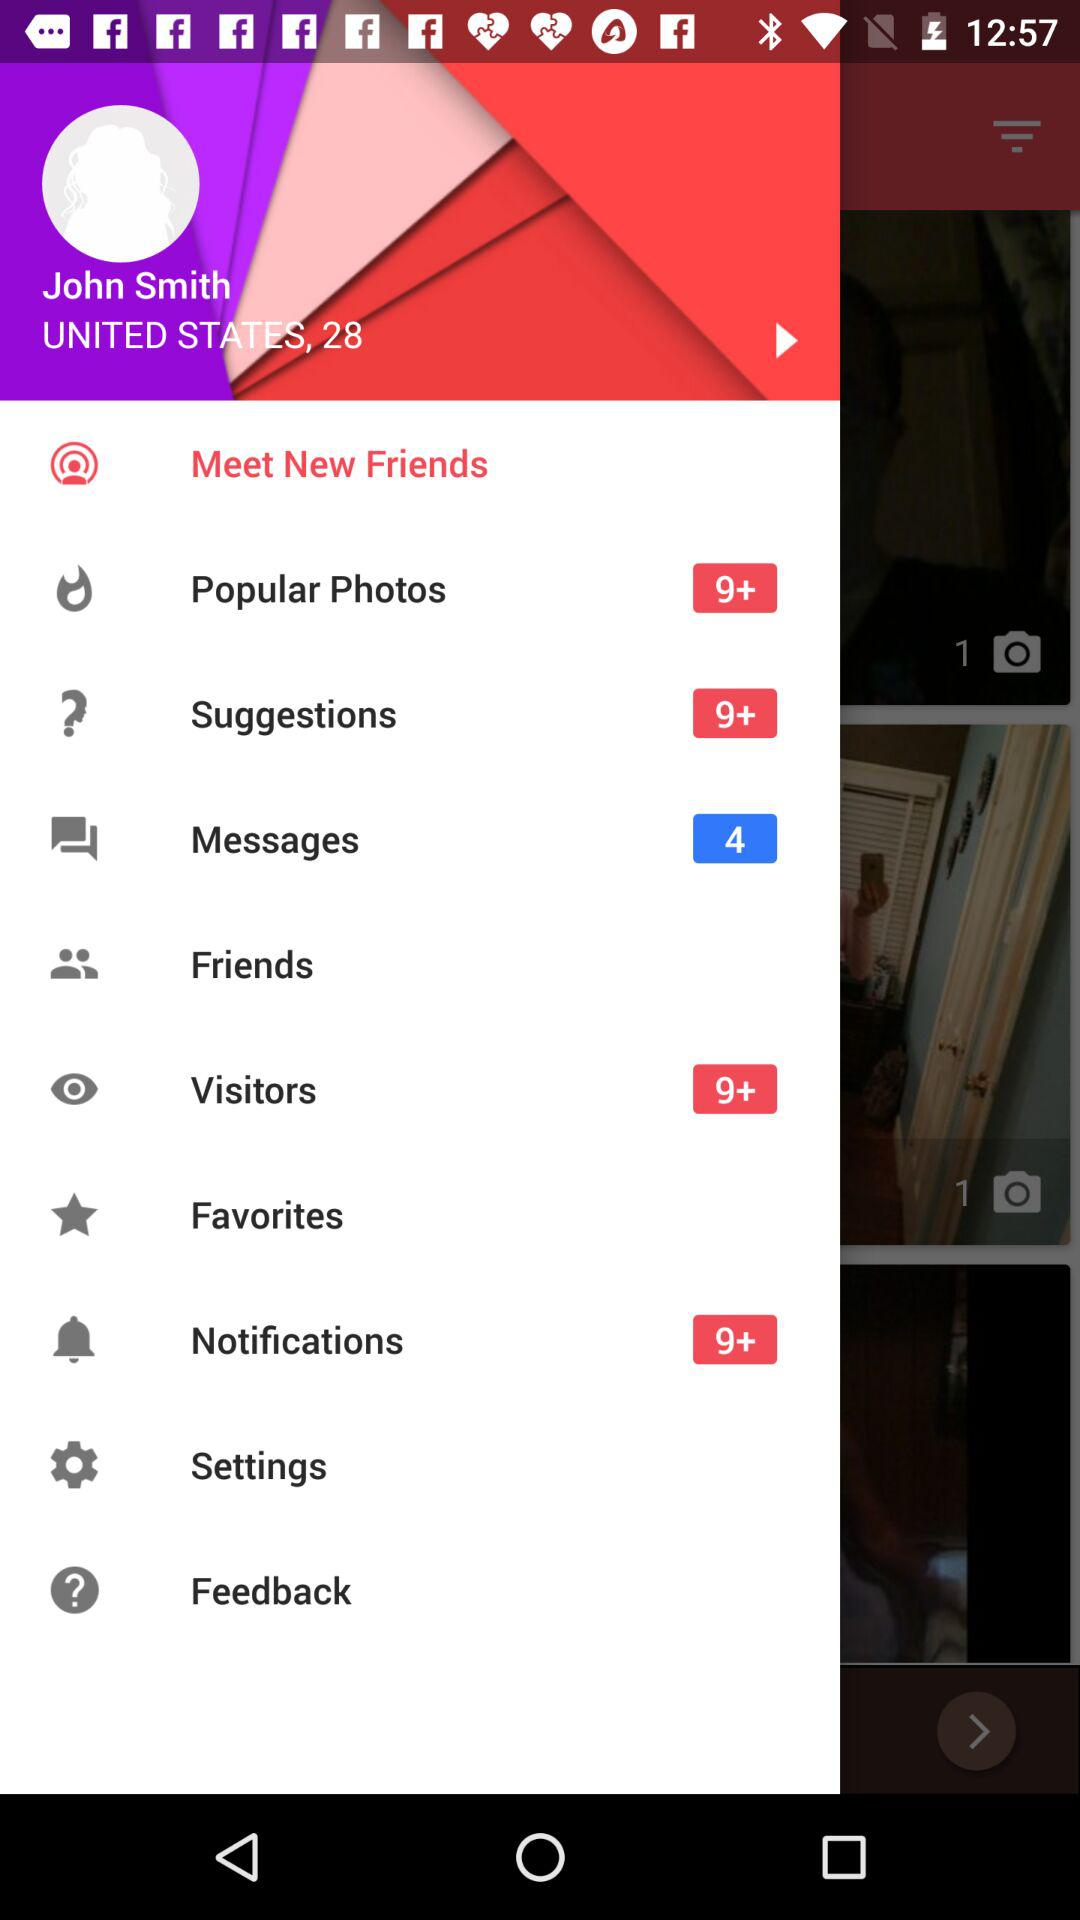How many visitors are there? There are more than 9 visitors. 